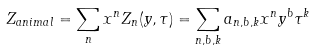<formula> <loc_0><loc_0><loc_500><loc_500>Z _ { a n i m a l } = \sum _ { n } x ^ { n } Z _ { n } ( y , \tau ) = \sum _ { n , b , k } a _ { n , b , k } x ^ { n } y ^ { b } \tau ^ { k }</formula> 